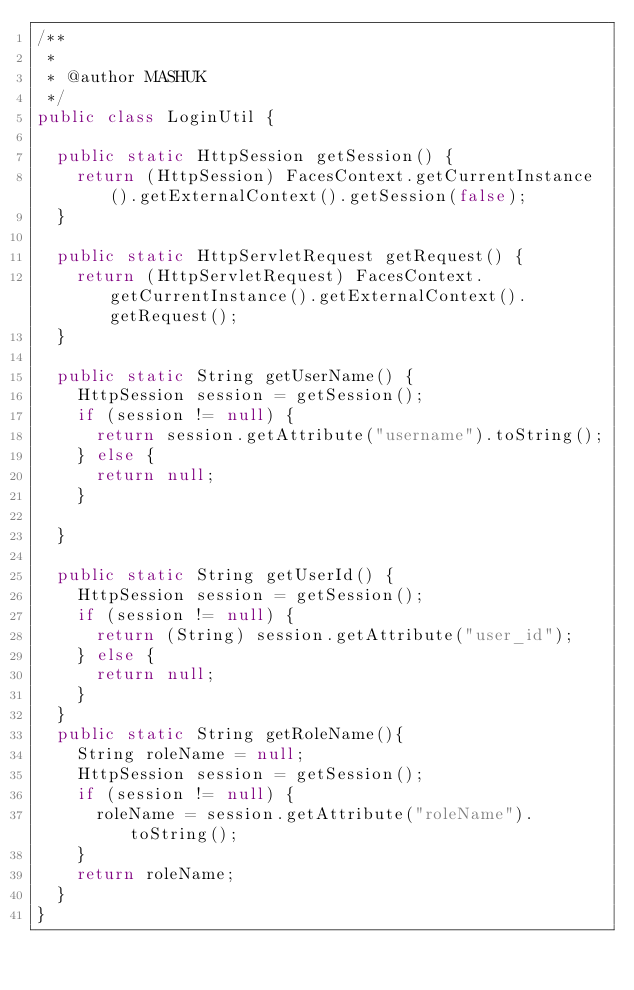Convert code to text. <code><loc_0><loc_0><loc_500><loc_500><_Java_>/**
 *
 * @author MASHUK
 */
public class LoginUtil {

  public static HttpSession getSession() {
    return (HttpSession) FacesContext.getCurrentInstance().getExternalContext().getSession(false);
  }

  public static HttpServletRequest getRequest() {
    return (HttpServletRequest) FacesContext.getCurrentInstance().getExternalContext().getRequest();
  }

  public static String getUserName() {
    HttpSession session = getSession();
    if (session != null) {
      return session.getAttribute("username").toString();
    } else {
      return null;
    }
    
  }

  public static String getUserId() {
    HttpSession session = getSession();
    if (session != null) {
      return (String) session.getAttribute("user_id");
    } else {
      return null;
    }
  }
  public static String getRoleName(){
    String roleName = null;
    HttpSession session = getSession();
    if (session != null) {
      roleName = session.getAttribute("roleName").toString();
    } 
    return roleName;
  }
}
</code> 